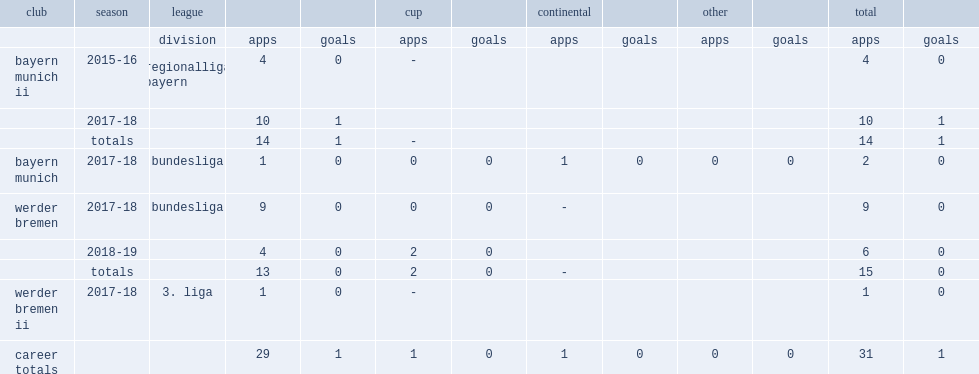Which league marco friedl made his debut in the regionalliga bayern with bayern munich ii in the 2015-16 season. Regionalliga bayern. 